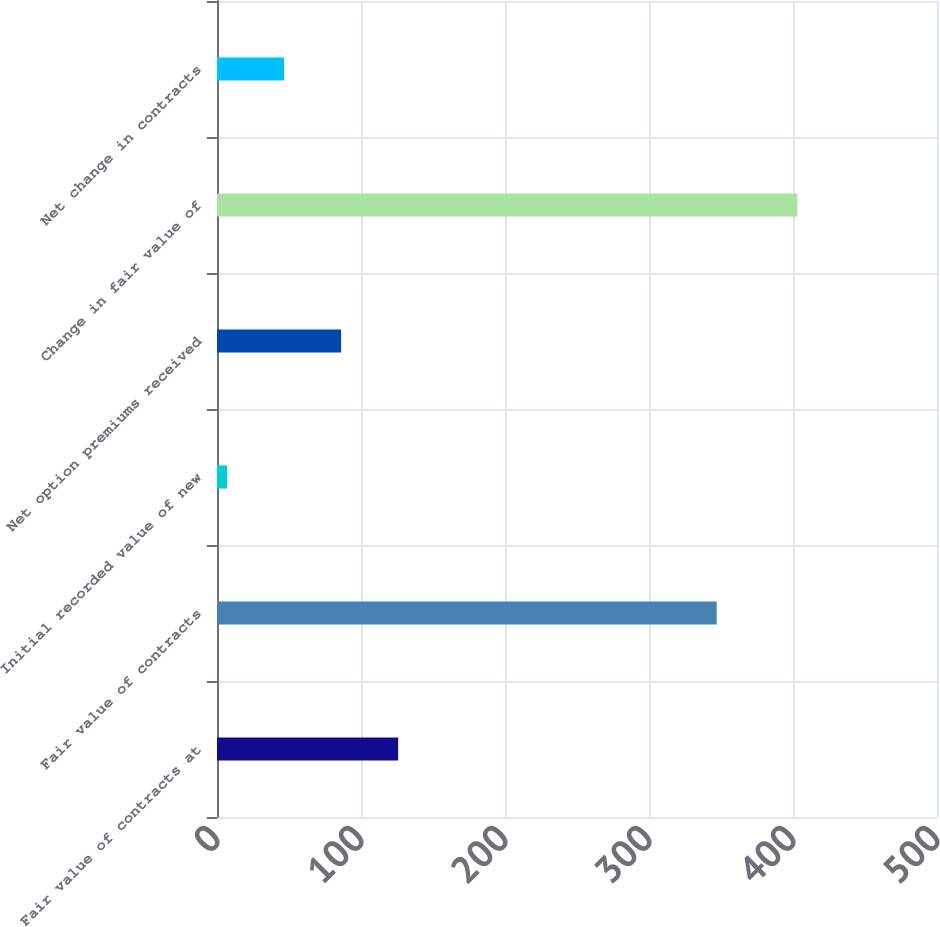Convert chart. <chart><loc_0><loc_0><loc_500><loc_500><bar_chart><fcel>Fair value of contracts at<fcel>Fair value of contracts<fcel>Initial recorded value of new<fcel>Net option premiums received<fcel>Change in fair value of<fcel>Net change in contracts<nl><fcel>125.8<fcel>347<fcel>7<fcel>86.2<fcel>403<fcel>46.6<nl></chart> 